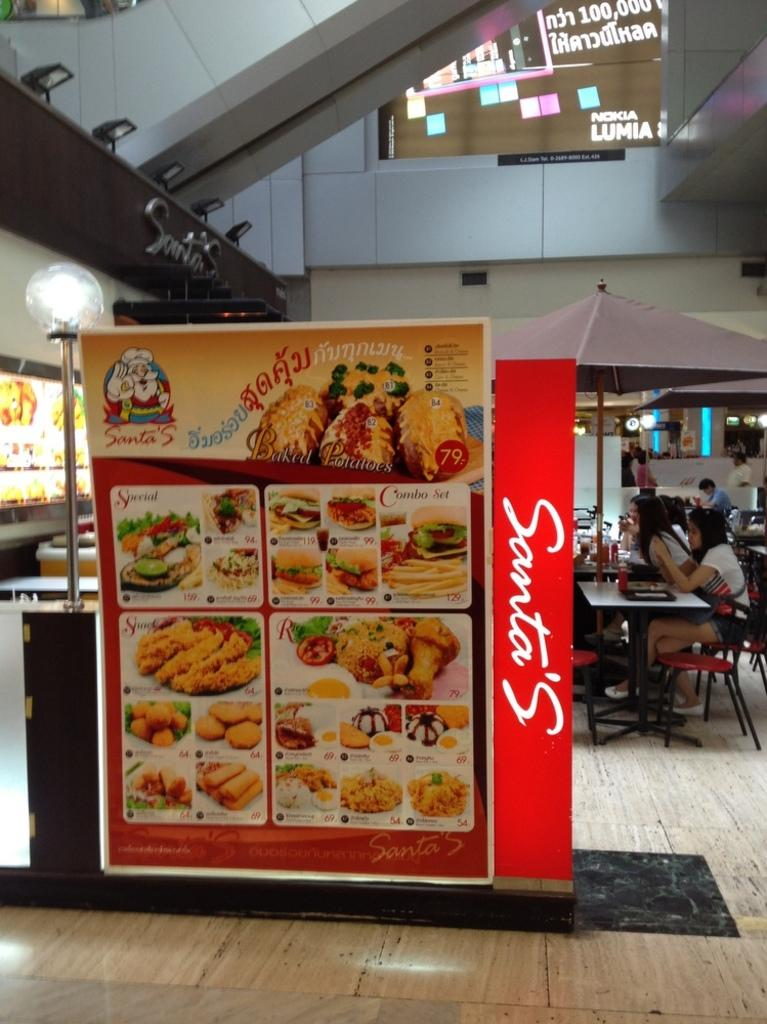What is the main object in the foreground of the image? There is a food menu in the foreground of the image. What can be seen happening in the background of the image? There are people sitting at a table in the background of the image, and they are having their food. What is the purpose of the ducks in the image? There are no ducks present in the image, so it is not possible to determine their purpose. 